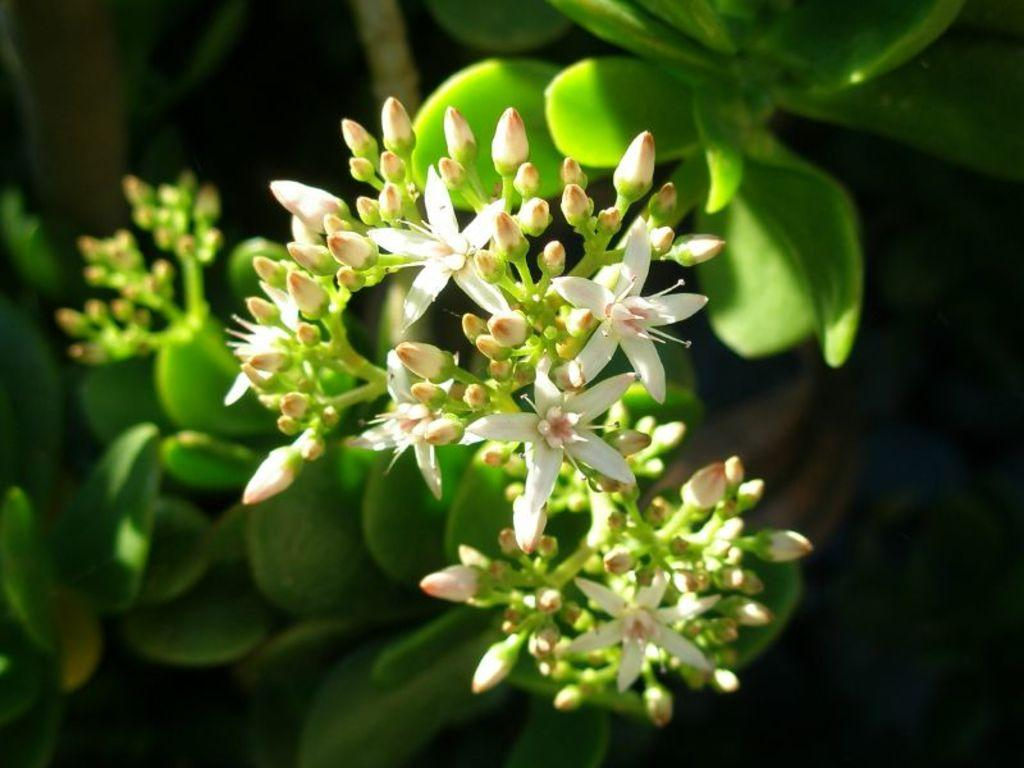What type of plant can be seen in the image? There is a tree in the image. What is the color of the tree? The tree is green in color. Are there any other plants or flowers near the tree? Yes, there are flowers near the tree. What colors are the flowers? The flowers are white and pink in color. What is the background of the image? The background of the image is black. What type of haircut does the tree have in the image? The tree does not have a haircut, as it is a plant and not a person. 